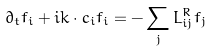<formula> <loc_0><loc_0><loc_500><loc_500>\partial _ { t } f _ { i } + i { k } \cdot { c } _ { i } f _ { i } = - \sum _ { j } L _ { i j } ^ { R } f _ { j }</formula> 